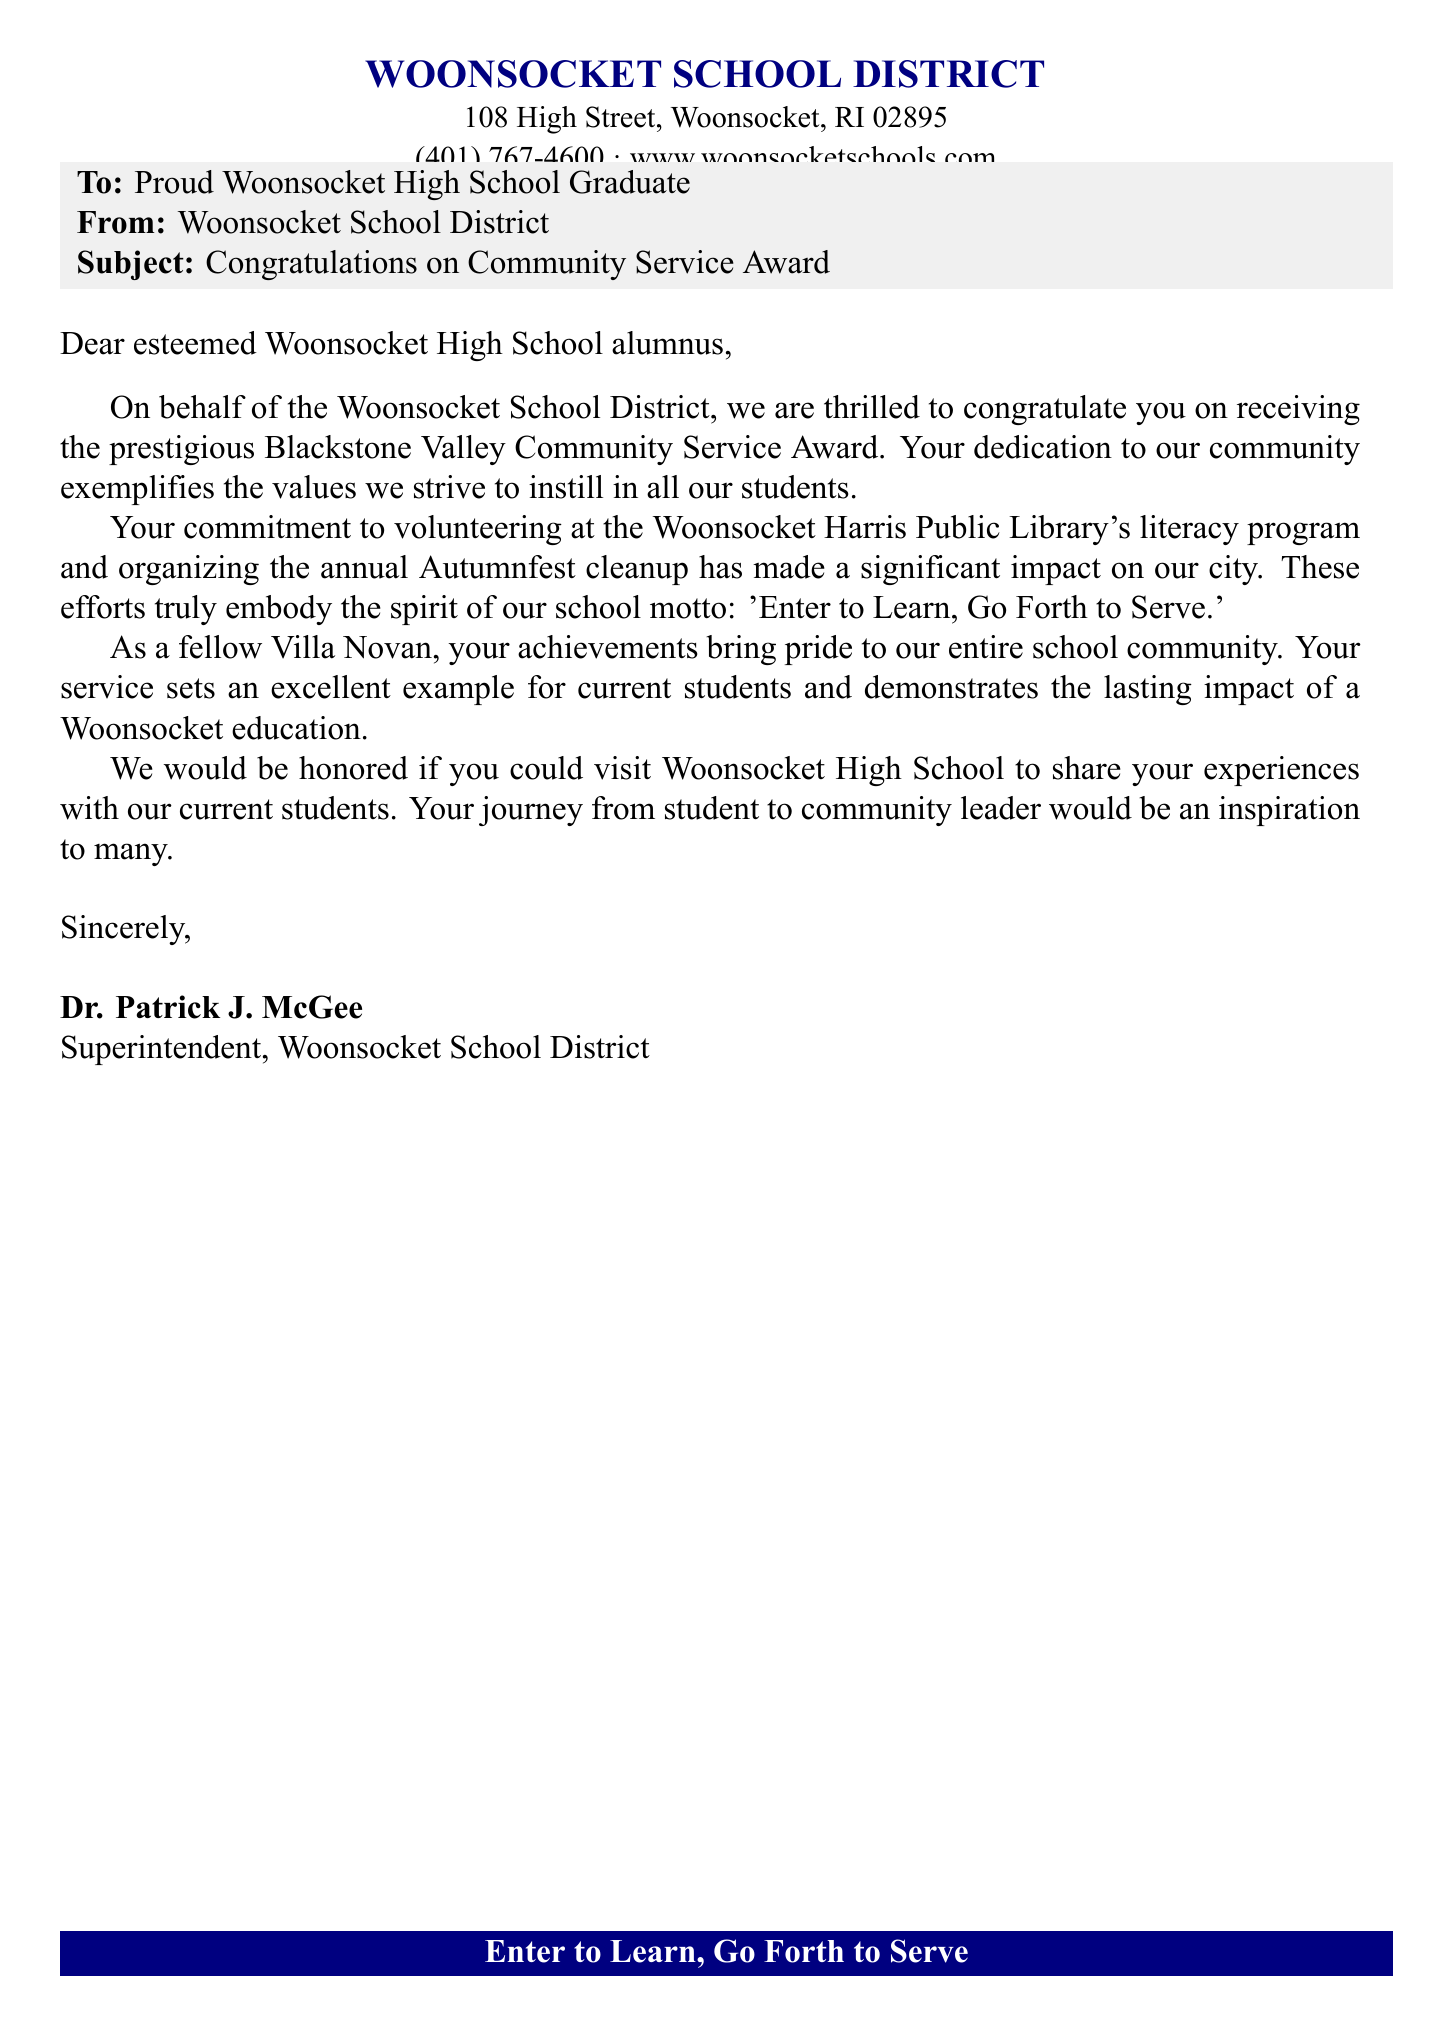What award did the graduate receive? The document states that the graduate received the Blackstone Valley Community Service Award.
Answer: Blackstone Valley Community Service Award Who is the sender of the fax? The document indicates that the sender is the Woonsocket School District.
Answer: Woonsocket School District What is the main purpose of the fax? The document's subject line indicates the purpose is to congratulate the recipient on their community service award.
Answer: To congratulate What program did the graduate volunteer for? The document mentions that the graduate volunteered at the Woonsocket Harris Public Library's literacy program.
Answer: Woonsocket Harris Public Library's literacy program Who signed the fax? The document shows that the fax is signed by Dr. Patrick J. McGee.
Answer: Dr. Patrick J. McGee What school did the recipient graduate from? The document refers to the recipient as a proud Woonsocket High School graduate.
Answer: Woonsocket High School What does the school motto emphasize? The document quotes the school motto as 'Enter to Learn, Go Forth to Serve,' which emphasizes service.
Answer: Enter to Learn, Go Forth to Serve What type of event is mentioned in relation to the graduate’s volunteering? The document states that the graduate organized the annual Autumnfest cleanup, which is an event.
Answer: Autumnfest cleanup 